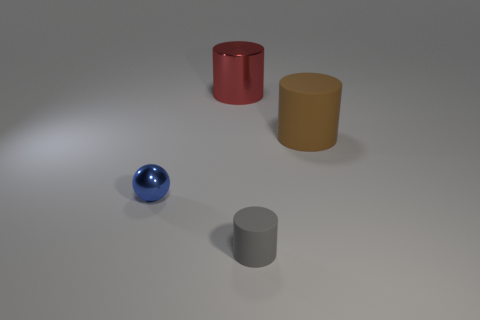There is a big thing to the left of the small object that is to the right of the metallic object on the right side of the small blue metallic sphere; what is it made of?
Provide a short and direct response. Metal. Is the number of small things right of the large metal object less than the number of red shiny balls?
Your answer should be very brief. No. There is a object that is the same size as the red cylinder; what material is it?
Keep it short and to the point. Rubber. What is the size of the object that is left of the tiny gray rubber cylinder and on the right side of the metallic ball?
Make the answer very short. Large. The red metal object that is the same shape as the tiny gray object is what size?
Provide a succinct answer. Large. What number of objects are large brown objects or rubber objects to the right of the small matte object?
Offer a very short reply. 1. There is a big brown matte thing; what shape is it?
Your answer should be very brief. Cylinder. What shape is the metal thing that is in front of the big thing on the right side of the large red object?
Offer a terse response. Sphere. What is the color of the small cylinder that is the same material as the large brown object?
Make the answer very short. Gray. Is there anything else that has the same size as the gray object?
Provide a short and direct response. Yes. 